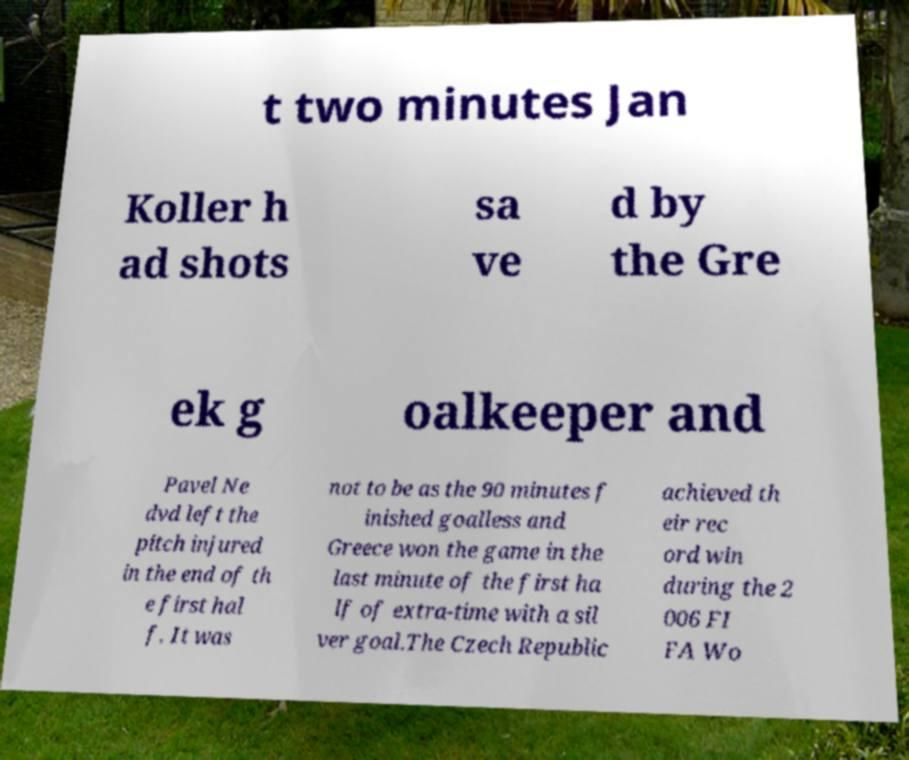There's text embedded in this image that I need extracted. Can you transcribe it verbatim? t two minutes Jan Koller h ad shots sa ve d by the Gre ek g oalkeeper and Pavel Ne dvd left the pitch injured in the end of th e first hal f. It was not to be as the 90 minutes f inished goalless and Greece won the game in the last minute of the first ha lf of extra-time with a sil ver goal.The Czech Republic achieved th eir rec ord win during the 2 006 FI FA Wo 